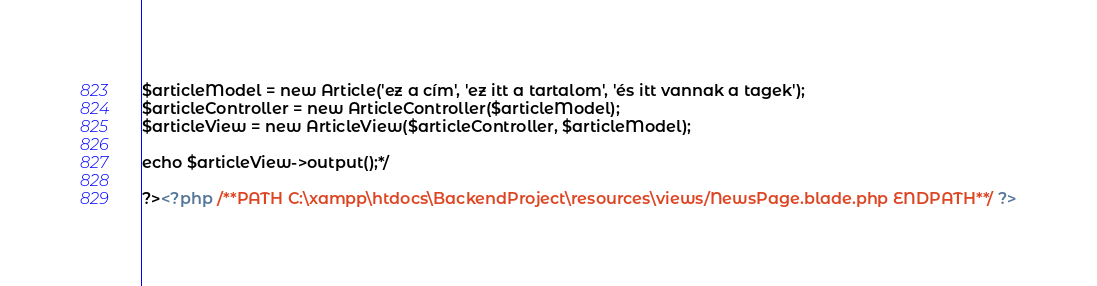<code> <loc_0><loc_0><loc_500><loc_500><_PHP_>$articleModel = new Article('ez a cím', 'ez itt a tartalom', 'és itt vannak a tagek');
$articleController = new ArticleController($articleModel);
$articleView = new ArticleView($articleController, $articleModel);

echo $articleView->output();*/

?><?php /**PATH C:\xampp\htdocs\BackendProject\resources\views/NewsPage.blade.php ENDPATH**/ ?></code> 